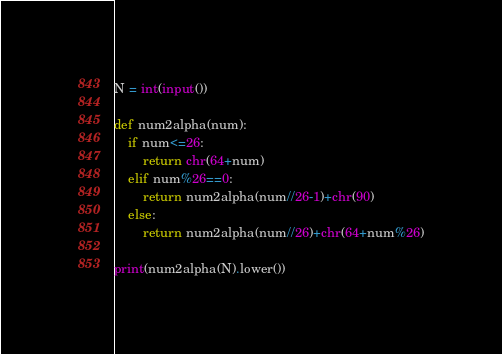<code> <loc_0><loc_0><loc_500><loc_500><_Python_>N = int(input())

def num2alpha(num):
    if num<=26:
        return chr(64+num)
    elif num%26==0:
        return num2alpha(num//26-1)+chr(90)
    else:
        return num2alpha(num//26)+chr(64+num%26)

print(num2alpha(N).lower())</code> 